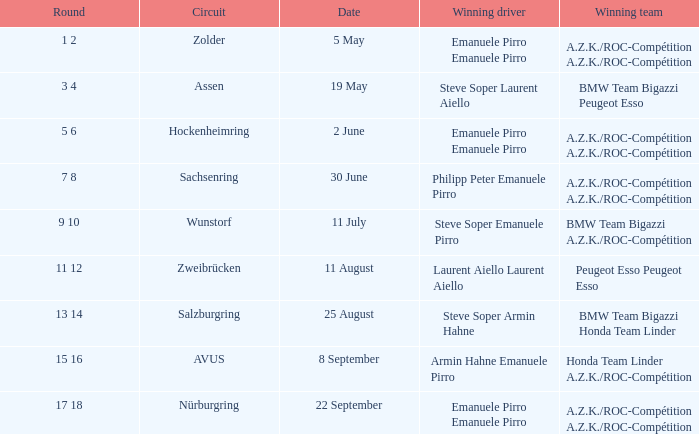What is the round on 30 june where a.z.k./roc-compétition emerges as the winning squad? 7 8. 